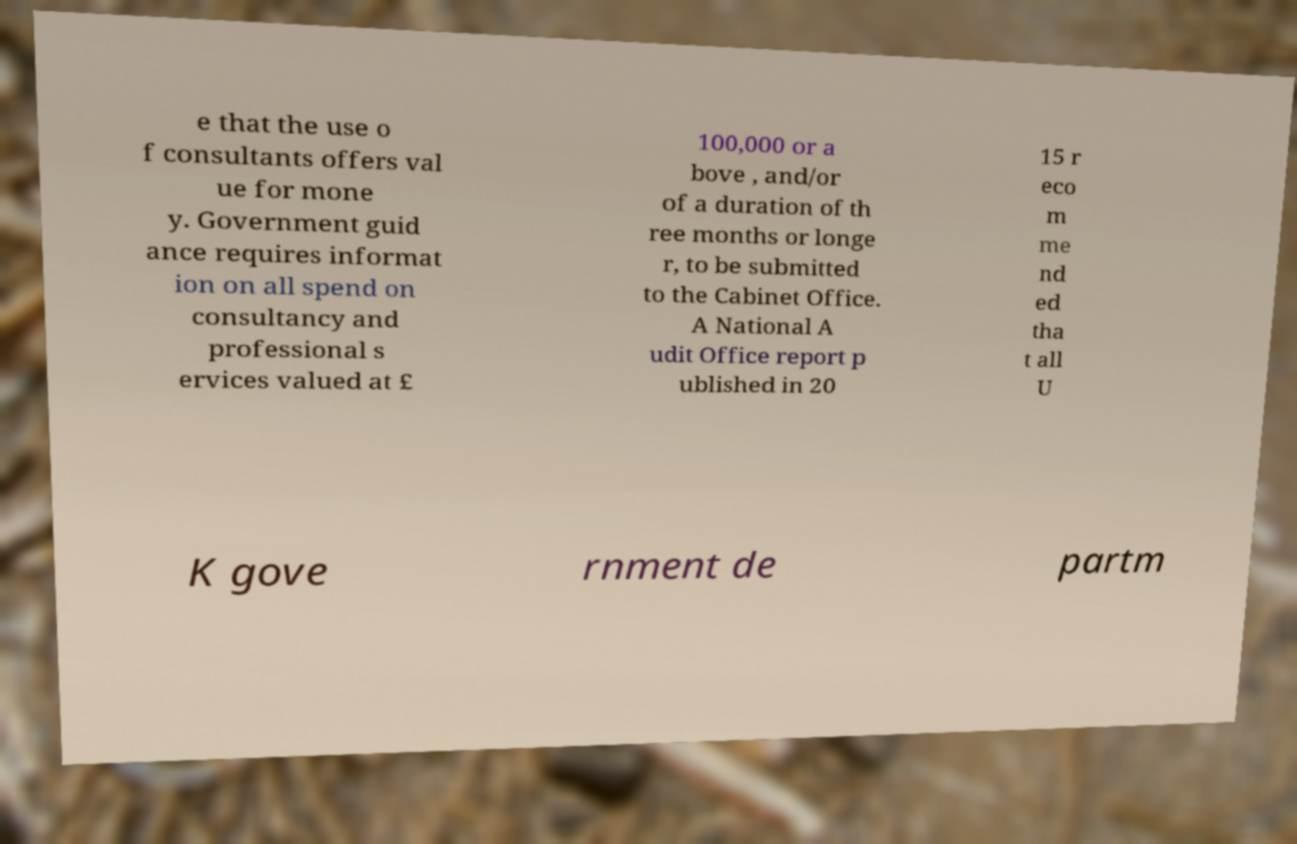Can you accurately transcribe the text from the provided image for me? e that the use o f consultants offers val ue for mone y. Government guid ance requires informat ion on all spend on consultancy and professional s ervices valued at £ 100,000 or a bove , and/or of a duration of th ree months or longe r, to be submitted to the Cabinet Office. A National A udit Office report p ublished in 20 15 r eco m me nd ed tha t all U K gove rnment de partm 